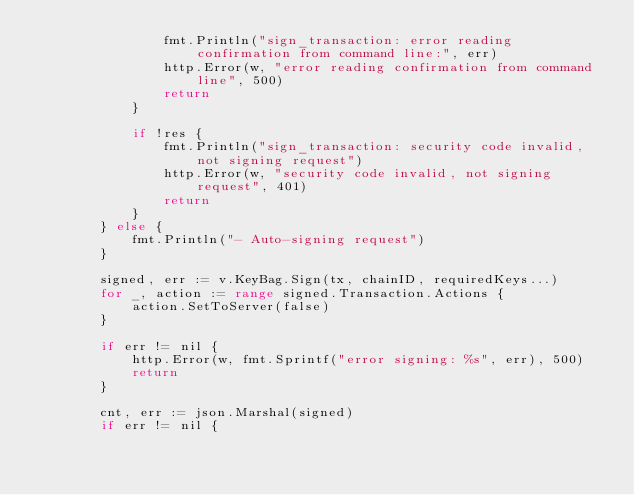<code> <loc_0><loc_0><loc_500><loc_500><_Go_>				fmt.Println("sign_transaction: error reading confirmation from command line:", err)
				http.Error(w, "error reading confirmation from command line", 500)
				return
			}

			if !res {
				fmt.Println("sign_transaction: security code invalid, not signing request")
				http.Error(w, "security code invalid, not signing request", 401)
				return
			}
		} else {
			fmt.Println("- Auto-signing request")
		}

		signed, err := v.KeyBag.Sign(tx, chainID, requiredKeys...)
		for _, action := range signed.Transaction.Actions {
			action.SetToServer(false)
		}

		if err != nil {
			http.Error(w, fmt.Sprintf("error signing: %s", err), 500)
			return
		}

		cnt, err := json.Marshal(signed)
		if err != nil {</code> 